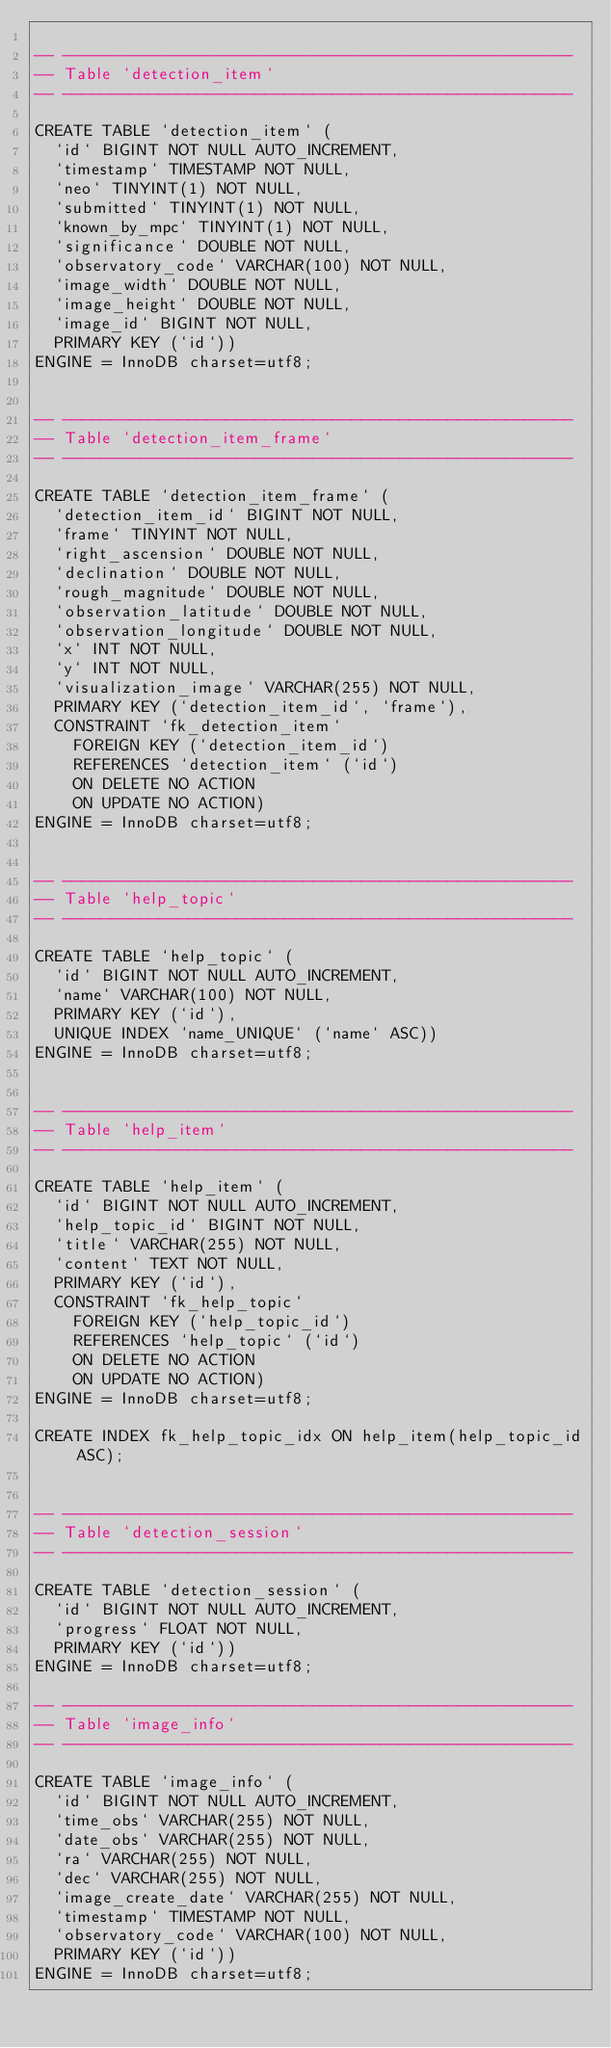<code> <loc_0><loc_0><loc_500><loc_500><_SQL_>
-- -----------------------------------------------------
-- Table `detection_item`
-- -----------------------------------------------------

CREATE TABLE `detection_item` (
  `id` BIGINT NOT NULL AUTO_INCREMENT,
  `timestamp` TIMESTAMP NOT NULL,
  `neo` TINYINT(1) NOT NULL,
  `submitted` TINYINT(1) NOT NULL,
  `known_by_mpc` TINYINT(1) NOT NULL,
  `significance` DOUBLE NOT NULL,
  `observatory_code` VARCHAR(100) NOT NULL,
  `image_width` DOUBLE NOT NULL,
  `image_height` DOUBLE NOT NULL,
  `image_id` BIGINT NOT NULL,
  PRIMARY KEY (`id`))
ENGINE = InnoDB charset=utf8;


-- -----------------------------------------------------
-- Table `detection_item_frame`
-- -----------------------------------------------------

CREATE TABLE `detection_item_frame` (
  `detection_item_id` BIGINT NOT NULL,
  `frame` TINYINT NOT NULL,
  `right_ascension` DOUBLE NOT NULL,
  `declination` DOUBLE NOT NULL,
  `rough_magnitude` DOUBLE NOT NULL,
  `observation_latitude` DOUBLE NOT NULL,
  `observation_longitude` DOUBLE NOT NULL,
  `x` INT NOT NULL,
  `y` INT NOT NULL,
  `visualization_image` VARCHAR(255) NOT NULL,
  PRIMARY KEY (`detection_item_id`, `frame`),
  CONSTRAINT `fk_detection_item`
    FOREIGN KEY (`detection_item_id`)
    REFERENCES `detection_item` (`id`)
    ON DELETE NO ACTION
    ON UPDATE NO ACTION)
ENGINE = InnoDB charset=utf8;


-- -----------------------------------------------------
-- Table `help_topic`
-- -----------------------------------------------------

CREATE TABLE `help_topic` (
  `id` BIGINT NOT NULL AUTO_INCREMENT,
  `name` VARCHAR(100) NOT NULL,
  PRIMARY KEY (`id`),
  UNIQUE INDEX `name_UNIQUE` (`name` ASC))
ENGINE = InnoDB charset=utf8;


-- -----------------------------------------------------
-- Table `help_item`
-- -----------------------------------------------------

CREATE TABLE `help_item` (
  `id` BIGINT NOT NULL AUTO_INCREMENT,
  `help_topic_id` BIGINT NOT NULL,
  `title` VARCHAR(255) NOT NULL,
  `content` TEXT NOT NULL,
  PRIMARY KEY (`id`),
  CONSTRAINT `fk_help_topic`
    FOREIGN KEY (`help_topic_id`)
    REFERENCES `help_topic` (`id`)
    ON DELETE NO ACTION
    ON UPDATE NO ACTION)
ENGINE = InnoDB charset=utf8;

CREATE INDEX fk_help_topic_idx ON help_item(help_topic_id ASC);  


-- -----------------------------------------------------
-- Table `detection_session`
-- -----------------------------------------------------

CREATE TABLE `detection_session` (
  `id` BIGINT NOT NULL AUTO_INCREMENT,
  `progress` FLOAT NOT NULL,
  PRIMARY KEY (`id`))
ENGINE = InnoDB charset=utf8;

-- -----------------------------------------------------
-- Table `image_info`
-- -----------------------------------------------------

CREATE TABLE `image_info` (
  `id` BIGINT NOT NULL AUTO_INCREMENT,
  `time_obs` VARCHAR(255) NOT NULL,
  `date_obs` VARCHAR(255) NOT NULL,
  `ra` VARCHAR(255) NOT NULL,
  `dec` VARCHAR(255) NOT NULL,
  `image_create_date` VARCHAR(255) NOT NULL,
  `timestamp` TIMESTAMP NOT NULL,
  `observatory_code` VARCHAR(100) NOT NULL,
  PRIMARY KEY (`id`))
ENGINE = InnoDB charset=utf8;
</code> 